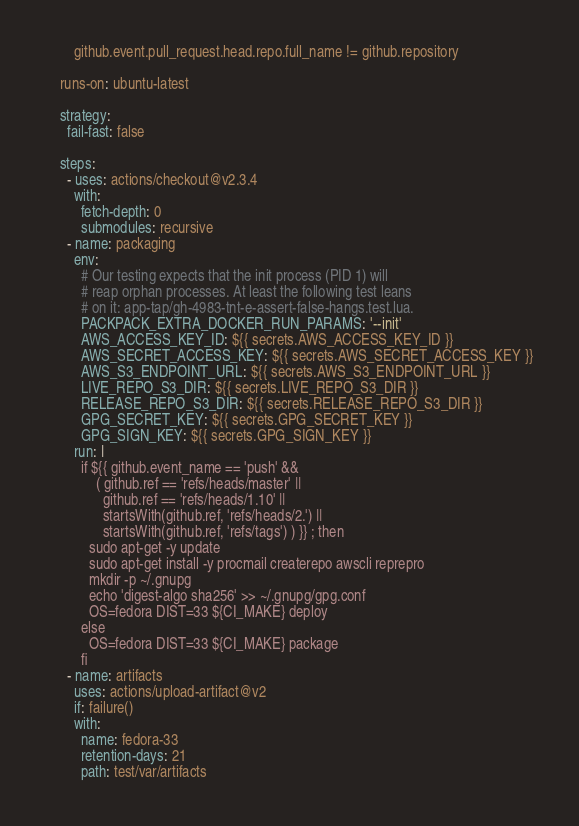<code> <loc_0><loc_0><loc_500><loc_500><_YAML_>        github.event.pull_request.head.repo.full_name != github.repository

    runs-on: ubuntu-latest

    strategy:
      fail-fast: false

    steps:
      - uses: actions/checkout@v2.3.4
        with:
          fetch-depth: 0
          submodules: recursive
      - name: packaging
        env:
          # Our testing expects that the init process (PID 1) will
          # reap orphan processes. At least the following test leans
          # on it: app-tap/gh-4983-tnt-e-assert-false-hangs.test.lua.
          PACKPACK_EXTRA_DOCKER_RUN_PARAMS: '--init'
          AWS_ACCESS_KEY_ID: ${{ secrets.AWS_ACCESS_KEY_ID }}
          AWS_SECRET_ACCESS_KEY: ${{ secrets.AWS_SECRET_ACCESS_KEY }}
          AWS_S3_ENDPOINT_URL: ${{ secrets.AWS_S3_ENDPOINT_URL }}
          LIVE_REPO_S3_DIR: ${{ secrets.LIVE_REPO_S3_DIR }}
          RELEASE_REPO_S3_DIR: ${{ secrets.RELEASE_REPO_S3_DIR }}
          GPG_SECRET_KEY: ${{ secrets.GPG_SECRET_KEY }}
          GPG_SIGN_KEY: ${{ secrets.GPG_SIGN_KEY }}
        run: |
          if ${{ github.event_name == 'push' &&
              ( github.ref == 'refs/heads/master' ||
                github.ref == 'refs/heads/1.10' ||
                startsWith(github.ref, 'refs/heads/2.') ||
                startsWith(github.ref, 'refs/tags') ) }} ; then
            sudo apt-get -y update
            sudo apt-get install -y procmail createrepo awscli reprepro
            mkdir -p ~/.gnupg
            echo 'digest-algo sha256' >> ~/.gnupg/gpg.conf
            OS=fedora DIST=33 ${CI_MAKE} deploy
          else
            OS=fedora DIST=33 ${CI_MAKE} package
          fi
      - name: artifacts
        uses: actions/upload-artifact@v2
        if: failure()
        with:
          name: fedora-33
          retention-days: 21
          path: test/var/artifacts
</code> 